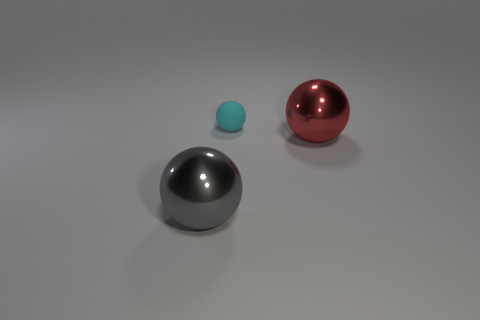Are there any other things that have the same material as the tiny object?
Your response must be concise. No. What size is the shiny sphere in front of the big red sphere right of the large sphere left of the tiny ball?
Your answer should be compact. Large. There is a large gray thing; does it have the same shape as the thing that is behind the red sphere?
Provide a succinct answer. Yes. Are there any other things of the same color as the tiny object?
Provide a succinct answer. No. How many spheres are either small yellow rubber things or red shiny objects?
Your answer should be very brief. 1. Are there any other big objects that have the same shape as the gray metal object?
Your answer should be compact. Yes. How many other things are there of the same color as the small matte ball?
Offer a terse response. 0. Is the number of big gray objects right of the big red ball less than the number of large red metal cubes?
Your response must be concise. No. How many large spheres are there?
Give a very brief answer. 2. How many tiny spheres are the same material as the gray object?
Your answer should be compact. 0. 